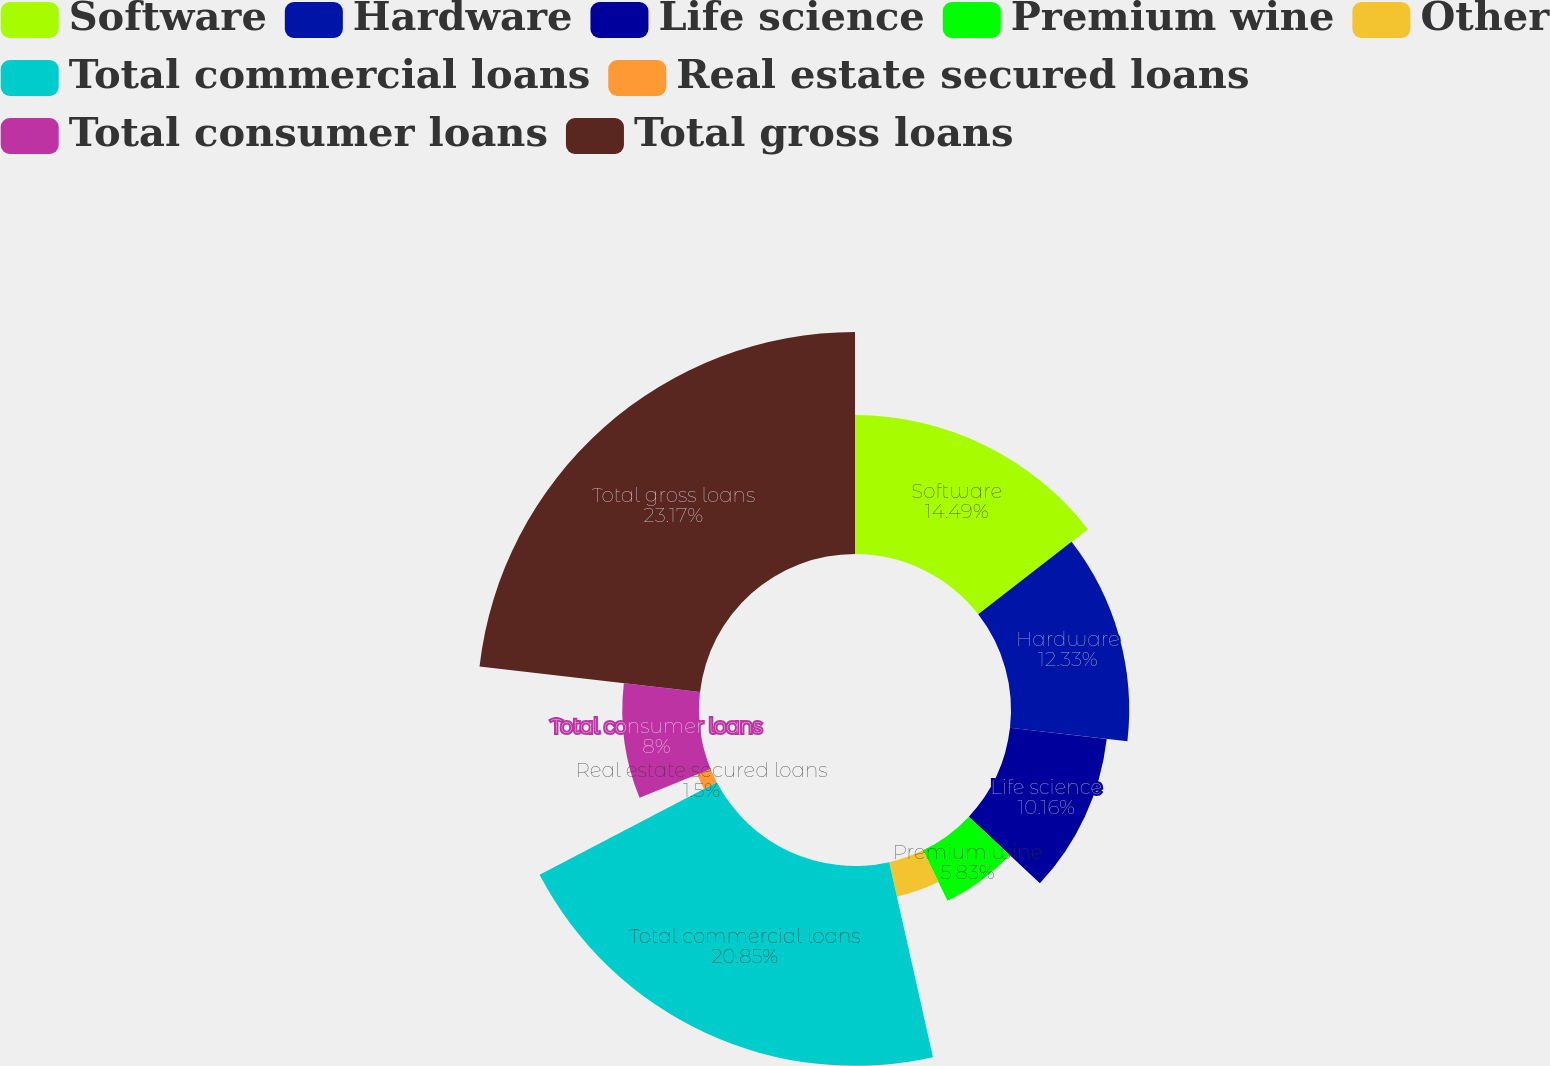Convert chart to OTSL. <chart><loc_0><loc_0><loc_500><loc_500><pie_chart><fcel>Software<fcel>Hardware<fcel>Life science<fcel>Premium wine<fcel>Other<fcel>Total commercial loans<fcel>Real estate secured loans<fcel>Total consumer loans<fcel>Total gross loans<nl><fcel>14.49%<fcel>12.33%<fcel>10.16%<fcel>5.83%<fcel>3.67%<fcel>20.85%<fcel>1.5%<fcel>8.0%<fcel>23.16%<nl></chart> 